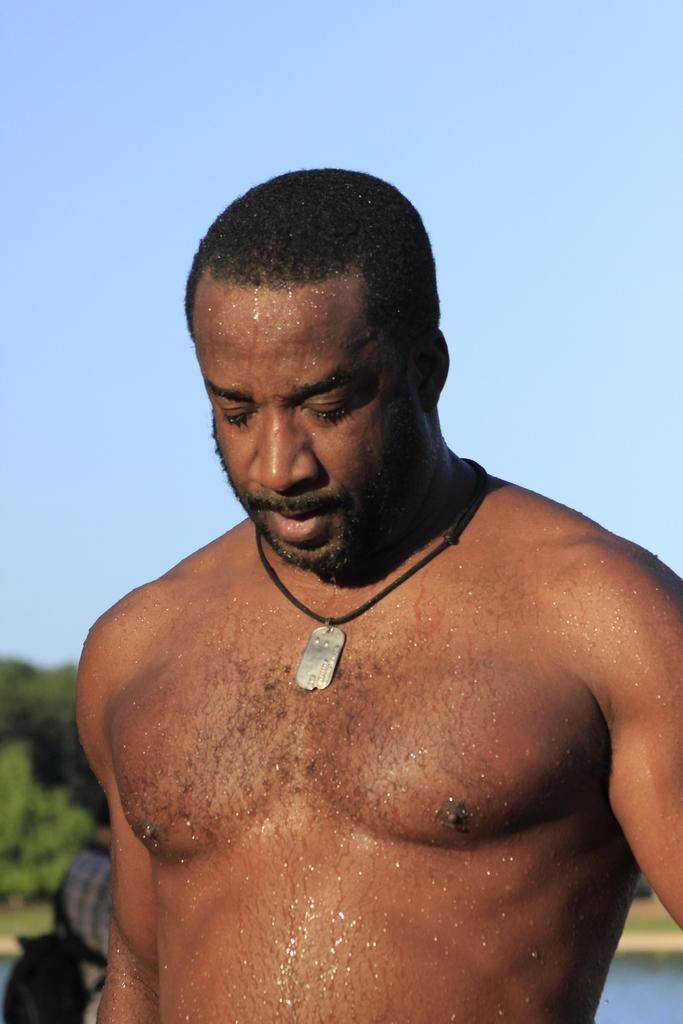How many people are in the image? There is one person in the image. Can you describe the person to the left of the first person? There is another person with a dress and a bag to the left of the first person. What can be seen in the background of the image? There are trees, water, and the sky visible in the background of the image. What type of fact can be seen in the person's eye in the image? There is no fact visible in anyone's eye in the image. How does the motion of the water affect the people in the image? The image does not show any motion of the water or any effect on the people. 